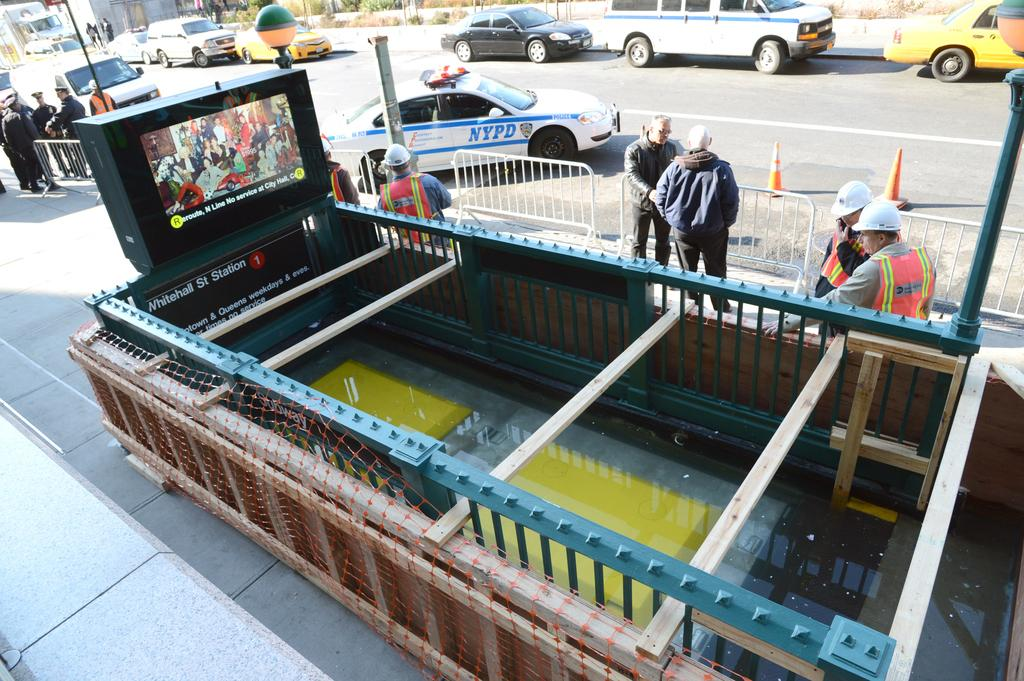<image>
Write a terse but informative summary of the picture. Construction workers stand outside of the Whitehall St. Station 